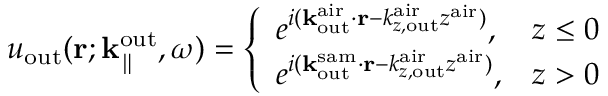<formula> <loc_0><loc_0><loc_500><loc_500>u _ { o u t } ( { r } ; { k } _ { \| } ^ { o u t } , \omega ) = \left \{ \begin{array} { l l } { e ^ { i ( { k } _ { o u t } ^ { a i r } \cdot { r } - k _ { z , o u t } ^ { a i r } z ^ { a i r } ) } , } & { z \leq 0 } \\ { e ^ { i ( { k } _ { o u t } ^ { s a m } \cdot { r } - k _ { z , o u t } ^ { a i r } z ^ { a i r } ) } , } & { z > 0 } \end{array}</formula> 